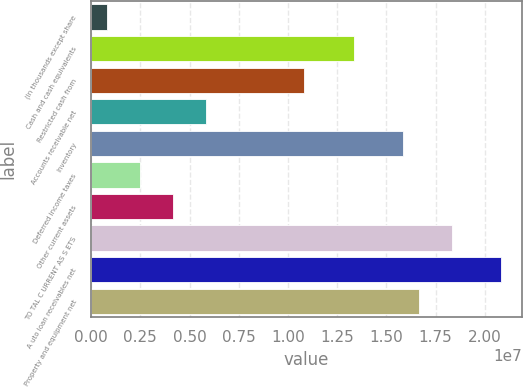<chart> <loc_0><loc_0><loc_500><loc_500><bar_chart><fcel>(In thousands except share<fcel>Cash and cash equivalents<fcel>Restricted cash from<fcel>Accounts receivable net<fcel>Inventory<fcel>Deferred income taxes<fcel>Other current assets<fcel>TO TAL C URRENT AS S ETS<fcel>A uto loan receivables net<fcel>Property and equipment net<nl><fcel>834003<fcel>1.33299e+07<fcel>1.08307e+07<fcel>5.83236e+06<fcel>1.58291e+07<fcel>2.50012e+06<fcel>4.16624e+06<fcel>1.83283e+07<fcel>2.08274e+07<fcel>1.66621e+07<nl></chart> 